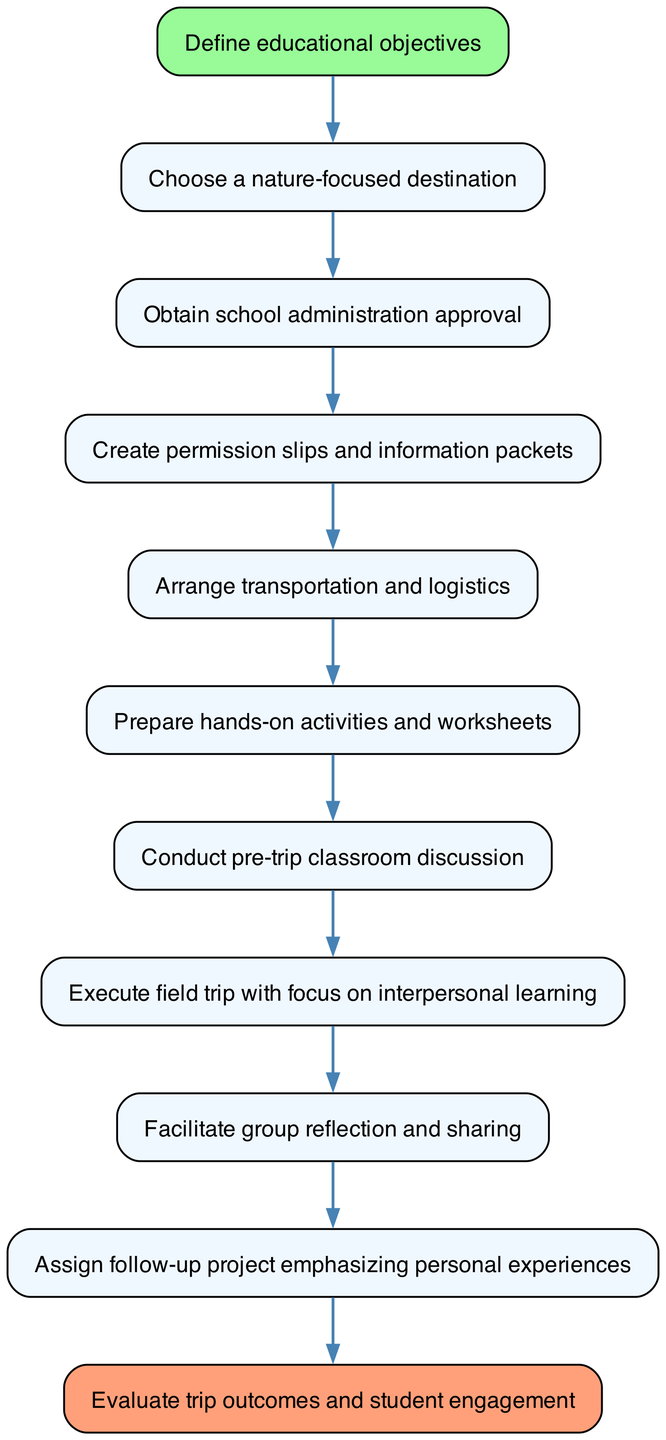What is the first step in the process? The diagram indicates that the first step is "Define educational objectives," which is the starting point of the flow.
Answer: Define educational objectives How many nodes are in the diagram? By counting each unique step or action represented, we find there are 11 nodes in total.
Answer: 11 What is the last step in the process? The final step listed in the diagram is "Evaluate trip outcomes and student engagement," which concludes the overall process.
Answer: Evaluate trip outcomes and student engagement Which step follows "Obtain school administration approval"? The next step after obtaining approval is "Create permission slips and information packets," as indicated by the flow direction.
Answer: Create permission slips and information packets What type of activities are prepared before the field trip? The diagram specifies "Prepare hands-on activities and worksheets" as the type of preparation that occurs before the execution of the field trip.
Answer: Prepare hands-on activities and worksheets What is the relationship between "Execute field trip" and "Facilitate group reflection and sharing"? The relationship is sequential, with "Execute field trip" leading directly to "Facilitate group reflection and sharing," showing the flow from action to reflection after the trip.
Answer: Sequential relationship During which step is a classroom discussion conducted? According to the flowchart, the classroom discussion occurs in the step labeled "Conduct pre-trip classroom discussion," which is before the field trip execution.
Answer: Conduct pre-trip classroom discussion What is emphasized in the follow-up project? The follow-up project emphasizes "personal experiences" as indicated in the diagram along with the assignment.
Answer: Personal experiences 